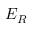<formula> <loc_0><loc_0><loc_500><loc_500>E _ { R }</formula> 